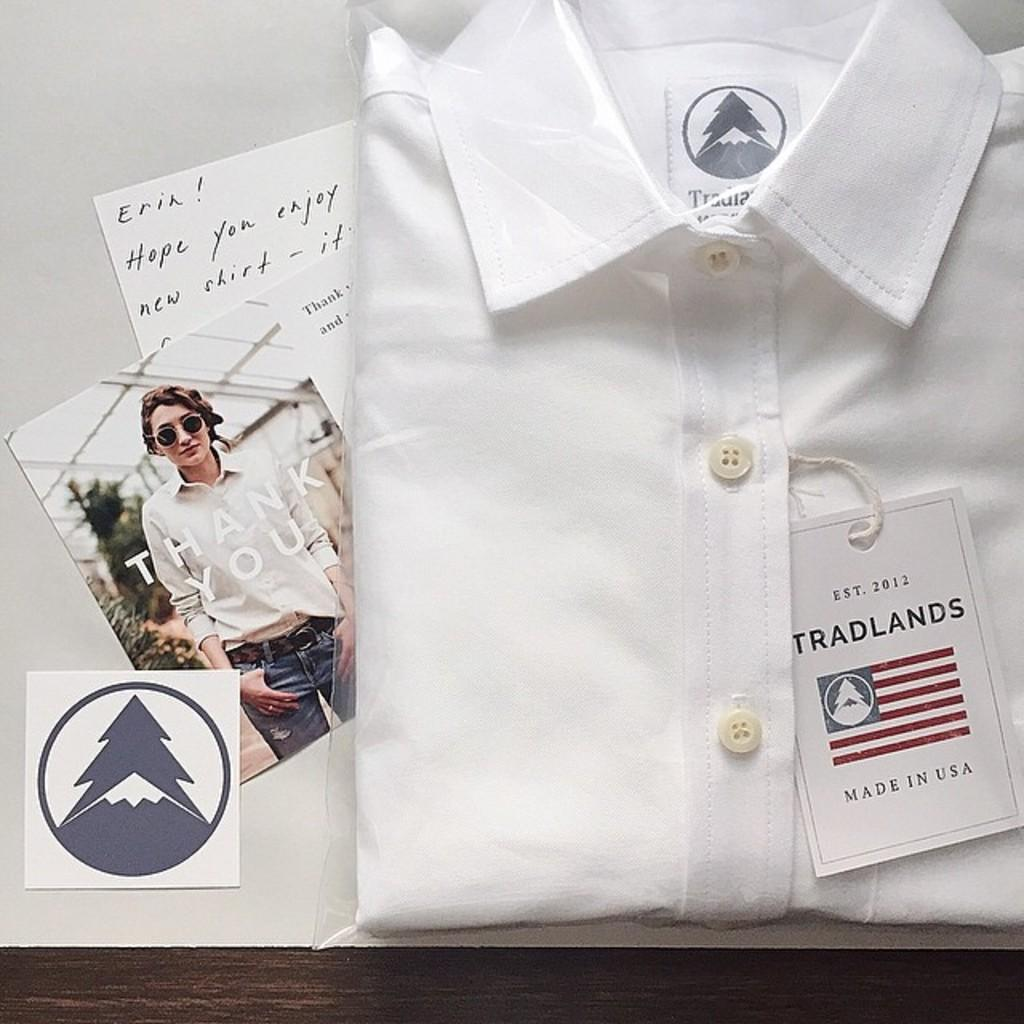What type of clothing item is visible in the image? There is a white color shirt with a tag in the image. What else can be seen on the shirt besides the tag? There is no additional information about the shirt's appearance provided in the facts. What is the paper used for in the image? The facts do not specify the purpose of the paper in the image. What are the photos of in the image? The facts do not provide information about the content of the photos. What color is the surface in the image? The surface in the image is white. What type of pets are visible in the image? There are no pets present in the image. What disease is being treated in the image? There is no indication of a disease or medical treatment in the image. 